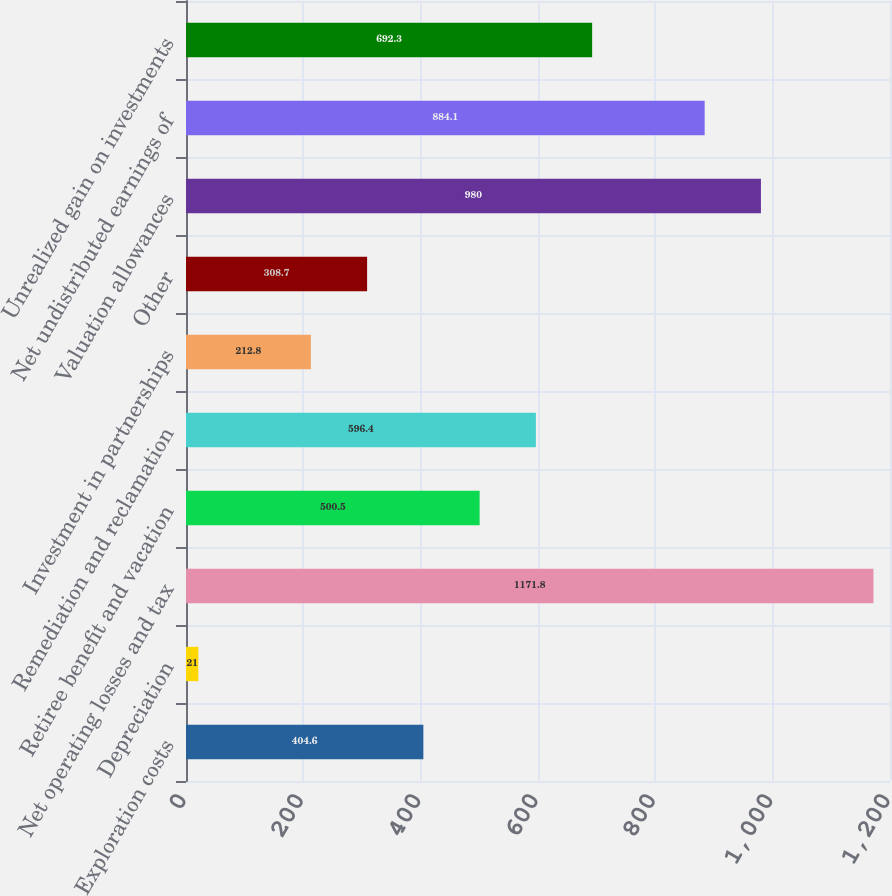Convert chart to OTSL. <chart><loc_0><loc_0><loc_500><loc_500><bar_chart><fcel>Exploration costs<fcel>Depreciation<fcel>Net operating losses and tax<fcel>Retiree benefit and vacation<fcel>Remediation and reclamation<fcel>Investment in partnerships<fcel>Other<fcel>Valuation allowances<fcel>Net undistributed earnings of<fcel>Unrealized gain on investments<nl><fcel>404.6<fcel>21<fcel>1171.8<fcel>500.5<fcel>596.4<fcel>212.8<fcel>308.7<fcel>980<fcel>884.1<fcel>692.3<nl></chart> 